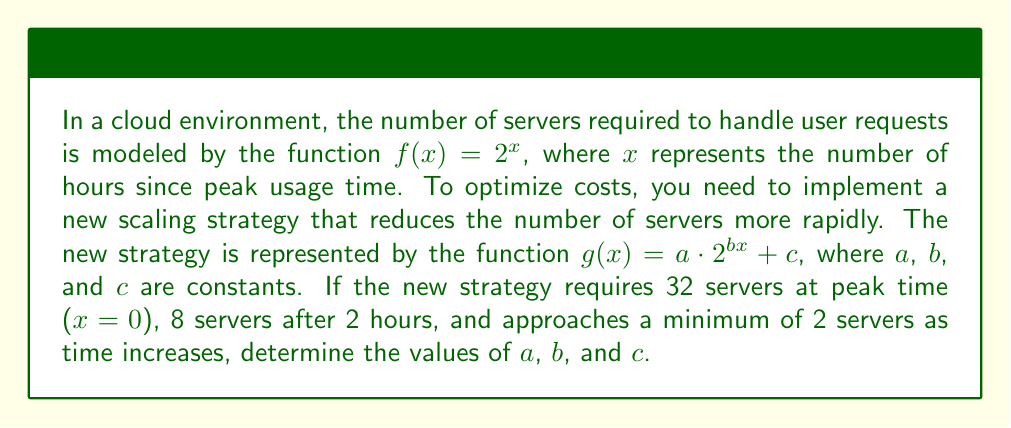Can you answer this question? Let's approach this step-by-step:

1) At peak time ($x = 0$), we need 32 servers:
   $g(0) = a \cdot 2^{b(0)} + c = a + c = 32$

2) After 2 hours ($x = 2$), we need 8 servers:
   $g(2) = a \cdot 2^{2b} + c = 8$

3) As $x$ approaches infinity, $g(x)$ approaches 2:
   $\lim_{x \to \infty} g(x) = \lim_{x \to \infty} (a \cdot 2^{bx} + c) = c = 2$

4) From step 3, we know $c = 2$. Substituting this into the equation from step 1:
   $a + 2 = 32$
   $a = 30$

5) Now we can use these values in the equation from step 2:
   $30 \cdot 2^{2b} + 2 = 8$
   $30 \cdot 2^{2b} = 6$
   $2^{2b} = \frac{1}{5}$

6) Solving for $b$:
   $2b = \log_2(\frac{1}{5}) = -\log_2(5)$
   $b = -\frac{1}{2}\log_2(5)$

Therefore, the transformed function is:

$$g(x) = 30 \cdot 2^{-\frac{1}{2}\log_2(5)x} + 2$$
Answer: $a = 30$, $b = -\frac{1}{2}\log_2(5)$, $c = 2$ 